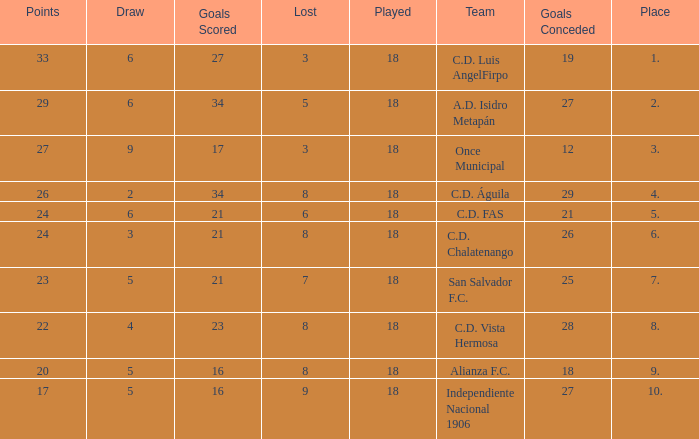For Once Municipal, what were the goals scored that had less than 27 points and greater than place 1? None. 